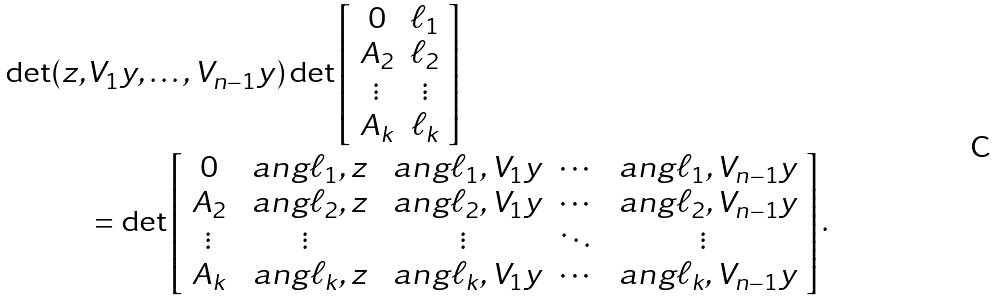<formula> <loc_0><loc_0><loc_500><loc_500>\det ( z , & V _ { 1 } y , \dots , V _ { n - 1 } y ) \det \left [ \begin{array} { c c } 0 & \ell _ { 1 } \\ A _ { 2 } & \ell _ { 2 } \\ \vdots & \vdots \\ A _ { k } & \ell _ { k } \end{array} \right ] \\ & = \det \left [ \begin{array} { c c c c c } 0 & \ a n g { \ell _ { 1 } , z } & \ a n g { \ell _ { 1 } , V _ { 1 } y } & \cdots & \ a n g { \ell _ { 1 } , V _ { n - 1 } y } \\ A _ { 2 } & \ a n g { \ell _ { 2 } , z } & \ a n g { \ell _ { 2 } , V _ { 1 } y } & \cdots & \ a n g { \ell _ { 2 } , V _ { n - 1 } y } \\ \vdots & \vdots & \vdots & \ddots & \vdots \\ A _ { k } & \ a n g { \ell _ { k } , z } & \ a n g { \ell _ { k } , V _ { 1 } y } & \cdots & \ a n g { \ell _ { k } , V _ { n - 1 } y } \end{array} \right ] .</formula> 